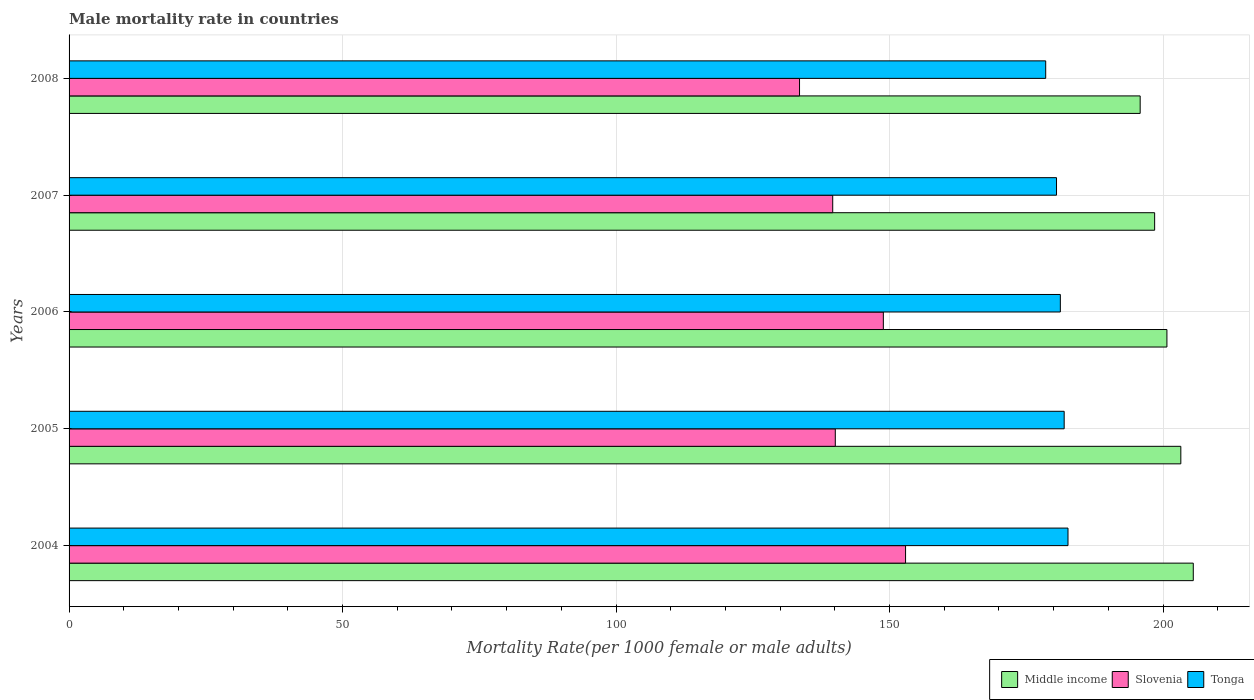How many groups of bars are there?
Ensure brevity in your answer.  5. Are the number of bars on each tick of the Y-axis equal?
Offer a terse response. Yes. How many bars are there on the 5th tick from the top?
Your answer should be compact. 3. How many bars are there on the 3rd tick from the bottom?
Your response must be concise. 3. What is the label of the 3rd group of bars from the top?
Keep it short and to the point. 2006. What is the male mortality rate in Slovenia in 2006?
Provide a succinct answer. 148.87. Across all years, what is the maximum male mortality rate in Tonga?
Provide a succinct answer. 182.63. Across all years, what is the minimum male mortality rate in Slovenia?
Give a very brief answer. 133.55. In which year was the male mortality rate in Middle income maximum?
Give a very brief answer. 2004. In which year was the male mortality rate in Slovenia minimum?
Your response must be concise. 2008. What is the total male mortality rate in Tonga in the graph?
Make the answer very short. 904.88. What is the difference between the male mortality rate in Tonga in 2004 and that in 2007?
Make the answer very short. 2.1. What is the difference between the male mortality rate in Slovenia in 2004 and the male mortality rate in Middle income in 2007?
Keep it short and to the point. -45.54. What is the average male mortality rate in Middle income per year?
Make the answer very short. 200.76. In the year 2005, what is the difference between the male mortality rate in Tonga and male mortality rate in Slovenia?
Make the answer very short. 41.84. What is the ratio of the male mortality rate in Tonga in 2005 to that in 2006?
Your answer should be compact. 1. Is the male mortality rate in Slovenia in 2004 less than that in 2005?
Ensure brevity in your answer.  No. What is the difference between the highest and the second highest male mortality rate in Slovenia?
Keep it short and to the point. 4.06. What is the difference between the highest and the lowest male mortality rate in Tonga?
Offer a very short reply. 4.07. In how many years, is the male mortality rate in Middle income greater than the average male mortality rate in Middle income taken over all years?
Your response must be concise. 2. Is the sum of the male mortality rate in Tonga in 2006 and 2007 greater than the maximum male mortality rate in Slovenia across all years?
Your answer should be compact. Yes. What does the 3rd bar from the bottom in 2004 represents?
Provide a short and direct response. Tonga. How many years are there in the graph?
Your answer should be compact. 5. What is the difference between two consecutive major ticks on the X-axis?
Keep it short and to the point. 50. Does the graph contain any zero values?
Your response must be concise. No. How many legend labels are there?
Give a very brief answer. 3. How are the legend labels stacked?
Make the answer very short. Horizontal. What is the title of the graph?
Make the answer very short. Male mortality rate in countries. What is the label or title of the X-axis?
Offer a very short reply. Mortality Rate(per 1000 female or male adults). What is the Mortality Rate(per 1000 female or male adults) of Middle income in 2004?
Your response must be concise. 205.53. What is the Mortality Rate(per 1000 female or male adults) of Slovenia in 2004?
Give a very brief answer. 152.93. What is the Mortality Rate(per 1000 female or male adults) of Tonga in 2004?
Keep it short and to the point. 182.63. What is the Mortality Rate(per 1000 female or male adults) of Middle income in 2005?
Provide a short and direct response. 203.26. What is the Mortality Rate(per 1000 female or male adults) in Slovenia in 2005?
Make the answer very short. 140.09. What is the Mortality Rate(per 1000 female or male adults) of Tonga in 2005?
Your answer should be compact. 181.93. What is the Mortality Rate(per 1000 female or male adults) of Middle income in 2006?
Provide a succinct answer. 200.72. What is the Mortality Rate(per 1000 female or male adults) in Slovenia in 2006?
Give a very brief answer. 148.87. What is the Mortality Rate(per 1000 female or male adults) in Tonga in 2006?
Offer a terse response. 181.23. What is the Mortality Rate(per 1000 female or male adults) of Middle income in 2007?
Give a very brief answer. 198.47. What is the Mortality Rate(per 1000 female or male adults) of Slovenia in 2007?
Make the answer very short. 139.62. What is the Mortality Rate(per 1000 female or male adults) of Tonga in 2007?
Ensure brevity in your answer.  180.53. What is the Mortality Rate(per 1000 female or male adults) of Middle income in 2008?
Make the answer very short. 195.83. What is the Mortality Rate(per 1000 female or male adults) in Slovenia in 2008?
Offer a very short reply. 133.55. What is the Mortality Rate(per 1000 female or male adults) of Tonga in 2008?
Your answer should be compact. 178.56. Across all years, what is the maximum Mortality Rate(per 1000 female or male adults) in Middle income?
Your answer should be very brief. 205.53. Across all years, what is the maximum Mortality Rate(per 1000 female or male adults) in Slovenia?
Your answer should be very brief. 152.93. Across all years, what is the maximum Mortality Rate(per 1000 female or male adults) in Tonga?
Provide a succinct answer. 182.63. Across all years, what is the minimum Mortality Rate(per 1000 female or male adults) of Middle income?
Ensure brevity in your answer.  195.83. Across all years, what is the minimum Mortality Rate(per 1000 female or male adults) in Slovenia?
Provide a short and direct response. 133.55. Across all years, what is the minimum Mortality Rate(per 1000 female or male adults) in Tonga?
Your answer should be very brief. 178.56. What is the total Mortality Rate(per 1000 female or male adults) in Middle income in the graph?
Give a very brief answer. 1003.81. What is the total Mortality Rate(per 1000 female or male adults) of Slovenia in the graph?
Make the answer very short. 715.05. What is the total Mortality Rate(per 1000 female or male adults) in Tonga in the graph?
Ensure brevity in your answer.  904.88. What is the difference between the Mortality Rate(per 1000 female or male adults) of Middle income in 2004 and that in 2005?
Your answer should be compact. 2.28. What is the difference between the Mortality Rate(per 1000 female or male adults) in Slovenia in 2004 and that in 2005?
Keep it short and to the point. 12.85. What is the difference between the Mortality Rate(per 1000 female or male adults) of Tonga in 2004 and that in 2005?
Offer a terse response. 0.7. What is the difference between the Mortality Rate(per 1000 female or male adults) in Middle income in 2004 and that in 2006?
Provide a short and direct response. 4.82. What is the difference between the Mortality Rate(per 1000 female or male adults) in Slovenia in 2004 and that in 2006?
Your response must be concise. 4.06. What is the difference between the Mortality Rate(per 1000 female or male adults) of Tonga in 2004 and that in 2006?
Provide a succinct answer. 1.4. What is the difference between the Mortality Rate(per 1000 female or male adults) of Middle income in 2004 and that in 2007?
Keep it short and to the point. 7.06. What is the difference between the Mortality Rate(per 1000 female or male adults) in Slovenia in 2004 and that in 2007?
Your answer should be very brief. 13.32. What is the difference between the Mortality Rate(per 1000 female or male adults) in Tonga in 2004 and that in 2007?
Make the answer very short. 2.1. What is the difference between the Mortality Rate(per 1000 female or male adults) in Middle income in 2004 and that in 2008?
Give a very brief answer. 9.71. What is the difference between the Mortality Rate(per 1000 female or male adults) in Slovenia in 2004 and that in 2008?
Offer a terse response. 19.39. What is the difference between the Mortality Rate(per 1000 female or male adults) in Tonga in 2004 and that in 2008?
Make the answer very short. 4.07. What is the difference between the Mortality Rate(per 1000 female or male adults) of Middle income in 2005 and that in 2006?
Your answer should be compact. 2.54. What is the difference between the Mortality Rate(per 1000 female or male adults) of Slovenia in 2005 and that in 2006?
Ensure brevity in your answer.  -8.79. What is the difference between the Mortality Rate(per 1000 female or male adults) in Tonga in 2005 and that in 2006?
Keep it short and to the point. 0.7. What is the difference between the Mortality Rate(per 1000 female or male adults) of Middle income in 2005 and that in 2007?
Give a very brief answer. 4.79. What is the difference between the Mortality Rate(per 1000 female or male adults) of Slovenia in 2005 and that in 2007?
Keep it short and to the point. 0.47. What is the difference between the Mortality Rate(per 1000 female or male adults) of Tonga in 2005 and that in 2007?
Ensure brevity in your answer.  1.4. What is the difference between the Mortality Rate(per 1000 female or male adults) in Middle income in 2005 and that in 2008?
Your response must be concise. 7.43. What is the difference between the Mortality Rate(per 1000 female or male adults) of Slovenia in 2005 and that in 2008?
Your answer should be compact. 6.54. What is the difference between the Mortality Rate(per 1000 female or male adults) of Tonga in 2005 and that in 2008?
Make the answer very short. 3.38. What is the difference between the Mortality Rate(per 1000 female or male adults) in Middle income in 2006 and that in 2007?
Your response must be concise. 2.25. What is the difference between the Mortality Rate(per 1000 female or male adults) of Slovenia in 2006 and that in 2007?
Provide a short and direct response. 9.26. What is the difference between the Mortality Rate(per 1000 female or male adults) of Tonga in 2006 and that in 2007?
Offer a terse response. 0.7. What is the difference between the Mortality Rate(per 1000 female or male adults) of Middle income in 2006 and that in 2008?
Your answer should be compact. 4.89. What is the difference between the Mortality Rate(per 1000 female or male adults) of Slovenia in 2006 and that in 2008?
Ensure brevity in your answer.  15.32. What is the difference between the Mortality Rate(per 1000 female or male adults) in Tonga in 2006 and that in 2008?
Provide a succinct answer. 2.68. What is the difference between the Mortality Rate(per 1000 female or male adults) in Middle income in 2007 and that in 2008?
Offer a very short reply. 2.64. What is the difference between the Mortality Rate(per 1000 female or male adults) of Slovenia in 2007 and that in 2008?
Your answer should be compact. 6.07. What is the difference between the Mortality Rate(per 1000 female or male adults) in Tonga in 2007 and that in 2008?
Your response must be concise. 1.98. What is the difference between the Mortality Rate(per 1000 female or male adults) in Middle income in 2004 and the Mortality Rate(per 1000 female or male adults) in Slovenia in 2005?
Your answer should be compact. 65.45. What is the difference between the Mortality Rate(per 1000 female or male adults) of Middle income in 2004 and the Mortality Rate(per 1000 female or male adults) of Tonga in 2005?
Ensure brevity in your answer.  23.61. What is the difference between the Mortality Rate(per 1000 female or male adults) of Slovenia in 2004 and the Mortality Rate(per 1000 female or male adults) of Tonga in 2005?
Provide a short and direct response. -29. What is the difference between the Mortality Rate(per 1000 female or male adults) of Middle income in 2004 and the Mortality Rate(per 1000 female or male adults) of Slovenia in 2006?
Provide a short and direct response. 56.66. What is the difference between the Mortality Rate(per 1000 female or male adults) of Middle income in 2004 and the Mortality Rate(per 1000 female or male adults) of Tonga in 2006?
Provide a succinct answer. 24.3. What is the difference between the Mortality Rate(per 1000 female or male adults) of Slovenia in 2004 and the Mortality Rate(per 1000 female or male adults) of Tonga in 2006?
Ensure brevity in your answer.  -28.3. What is the difference between the Mortality Rate(per 1000 female or male adults) in Middle income in 2004 and the Mortality Rate(per 1000 female or male adults) in Slovenia in 2007?
Your answer should be compact. 65.92. What is the difference between the Mortality Rate(per 1000 female or male adults) of Middle income in 2004 and the Mortality Rate(per 1000 female or male adults) of Tonga in 2007?
Ensure brevity in your answer.  25. What is the difference between the Mortality Rate(per 1000 female or male adults) of Slovenia in 2004 and the Mortality Rate(per 1000 female or male adults) of Tonga in 2007?
Ensure brevity in your answer.  -27.6. What is the difference between the Mortality Rate(per 1000 female or male adults) of Middle income in 2004 and the Mortality Rate(per 1000 female or male adults) of Slovenia in 2008?
Ensure brevity in your answer.  71.99. What is the difference between the Mortality Rate(per 1000 female or male adults) of Middle income in 2004 and the Mortality Rate(per 1000 female or male adults) of Tonga in 2008?
Make the answer very short. 26.98. What is the difference between the Mortality Rate(per 1000 female or male adults) in Slovenia in 2004 and the Mortality Rate(per 1000 female or male adults) in Tonga in 2008?
Ensure brevity in your answer.  -25.62. What is the difference between the Mortality Rate(per 1000 female or male adults) in Middle income in 2005 and the Mortality Rate(per 1000 female or male adults) in Slovenia in 2006?
Offer a very short reply. 54.39. What is the difference between the Mortality Rate(per 1000 female or male adults) of Middle income in 2005 and the Mortality Rate(per 1000 female or male adults) of Tonga in 2006?
Give a very brief answer. 22.03. What is the difference between the Mortality Rate(per 1000 female or male adults) of Slovenia in 2005 and the Mortality Rate(per 1000 female or male adults) of Tonga in 2006?
Provide a succinct answer. -41.15. What is the difference between the Mortality Rate(per 1000 female or male adults) of Middle income in 2005 and the Mortality Rate(per 1000 female or male adults) of Slovenia in 2007?
Provide a succinct answer. 63.64. What is the difference between the Mortality Rate(per 1000 female or male adults) in Middle income in 2005 and the Mortality Rate(per 1000 female or male adults) in Tonga in 2007?
Offer a terse response. 22.73. What is the difference between the Mortality Rate(per 1000 female or male adults) in Slovenia in 2005 and the Mortality Rate(per 1000 female or male adults) in Tonga in 2007?
Ensure brevity in your answer.  -40.45. What is the difference between the Mortality Rate(per 1000 female or male adults) in Middle income in 2005 and the Mortality Rate(per 1000 female or male adults) in Slovenia in 2008?
Give a very brief answer. 69.71. What is the difference between the Mortality Rate(per 1000 female or male adults) of Middle income in 2005 and the Mortality Rate(per 1000 female or male adults) of Tonga in 2008?
Your answer should be very brief. 24.7. What is the difference between the Mortality Rate(per 1000 female or male adults) in Slovenia in 2005 and the Mortality Rate(per 1000 female or male adults) in Tonga in 2008?
Offer a terse response. -38.47. What is the difference between the Mortality Rate(per 1000 female or male adults) in Middle income in 2006 and the Mortality Rate(per 1000 female or male adults) in Slovenia in 2007?
Offer a very short reply. 61.1. What is the difference between the Mortality Rate(per 1000 female or male adults) of Middle income in 2006 and the Mortality Rate(per 1000 female or male adults) of Tonga in 2007?
Ensure brevity in your answer.  20.19. What is the difference between the Mortality Rate(per 1000 female or male adults) of Slovenia in 2006 and the Mortality Rate(per 1000 female or male adults) of Tonga in 2007?
Keep it short and to the point. -31.66. What is the difference between the Mortality Rate(per 1000 female or male adults) of Middle income in 2006 and the Mortality Rate(per 1000 female or male adults) of Slovenia in 2008?
Offer a very short reply. 67.17. What is the difference between the Mortality Rate(per 1000 female or male adults) in Middle income in 2006 and the Mortality Rate(per 1000 female or male adults) in Tonga in 2008?
Offer a very short reply. 22.16. What is the difference between the Mortality Rate(per 1000 female or male adults) of Slovenia in 2006 and the Mortality Rate(per 1000 female or male adults) of Tonga in 2008?
Give a very brief answer. -29.68. What is the difference between the Mortality Rate(per 1000 female or male adults) of Middle income in 2007 and the Mortality Rate(per 1000 female or male adults) of Slovenia in 2008?
Your answer should be very brief. 64.92. What is the difference between the Mortality Rate(per 1000 female or male adults) in Middle income in 2007 and the Mortality Rate(per 1000 female or male adults) in Tonga in 2008?
Offer a very short reply. 19.92. What is the difference between the Mortality Rate(per 1000 female or male adults) of Slovenia in 2007 and the Mortality Rate(per 1000 female or male adults) of Tonga in 2008?
Offer a terse response. -38.94. What is the average Mortality Rate(per 1000 female or male adults) in Middle income per year?
Keep it short and to the point. 200.76. What is the average Mortality Rate(per 1000 female or male adults) of Slovenia per year?
Provide a short and direct response. 143.01. What is the average Mortality Rate(per 1000 female or male adults) of Tonga per year?
Make the answer very short. 180.98. In the year 2004, what is the difference between the Mortality Rate(per 1000 female or male adults) of Middle income and Mortality Rate(per 1000 female or male adults) of Slovenia?
Your response must be concise. 52.6. In the year 2004, what is the difference between the Mortality Rate(per 1000 female or male adults) of Middle income and Mortality Rate(per 1000 female or male adults) of Tonga?
Give a very brief answer. 22.91. In the year 2004, what is the difference between the Mortality Rate(per 1000 female or male adults) of Slovenia and Mortality Rate(per 1000 female or male adults) of Tonga?
Provide a short and direct response. -29.7. In the year 2005, what is the difference between the Mortality Rate(per 1000 female or male adults) of Middle income and Mortality Rate(per 1000 female or male adults) of Slovenia?
Offer a very short reply. 63.17. In the year 2005, what is the difference between the Mortality Rate(per 1000 female or male adults) in Middle income and Mortality Rate(per 1000 female or male adults) in Tonga?
Provide a short and direct response. 21.33. In the year 2005, what is the difference between the Mortality Rate(per 1000 female or male adults) in Slovenia and Mortality Rate(per 1000 female or male adults) in Tonga?
Your answer should be compact. -41.84. In the year 2006, what is the difference between the Mortality Rate(per 1000 female or male adults) in Middle income and Mortality Rate(per 1000 female or male adults) in Slovenia?
Provide a short and direct response. 51.85. In the year 2006, what is the difference between the Mortality Rate(per 1000 female or male adults) in Middle income and Mortality Rate(per 1000 female or male adults) in Tonga?
Your response must be concise. 19.49. In the year 2006, what is the difference between the Mortality Rate(per 1000 female or male adults) of Slovenia and Mortality Rate(per 1000 female or male adults) of Tonga?
Ensure brevity in your answer.  -32.36. In the year 2007, what is the difference between the Mortality Rate(per 1000 female or male adults) in Middle income and Mortality Rate(per 1000 female or male adults) in Slovenia?
Your answer should be very brief. 58.86. In the year 2007, what is the difference between the Mortality Rate(per 1000 female or male adults) of Middle income and Mortality Rate(per 1000 female or male adults) of Tonga?
Provide a succinct answer. 17.94. In the year 2007, what is the difference between the Mortality Rate(per 1000 female or male adults) in Slovenia and Mortality Rate(per 1000 female or male adults) in Tonga?
Your answer should be compact. -40.92. In the year 2008, what is the difference between the Mortality Rate(per 1000 female or male adults) in Middle income and Mortality Rate(per 1000 female or male adults) in Slovenia?
Your response must be concise. 62.28. In the year 2008, what is the difference between the Mortality Rate(per 1000 female or male adults) in Middle income and Mortality Rate(per 1000 female or male adults) in Tonga?
Offer a very short reply. 17.27. In the year 2008, what is the difference between the Mortality Rate(per 1000 female or male adults) in Slovenia and Mortality Rate(per 1000 female or male adults) in Tonga?
Provide a succinct answer. -45.01. What is the ratio of the Mortality Rate(per 1000 female or male adults) in Middle income in 2004 to that in 2005?
Your answer should be very brief. 1.01. What is the ratio of the Mortality Rate(per 1000 female or male adults) in Slovenia in 2004 to that in 2005?
Your response must be concise. 1.09. What is the ratio of the Mortality Rate(per 1000 female or male adults) of Middle income in 2004 to that in 2006?
Provide a succinct answer. 1.02. What is the ratio of the Mortality Rate(per 1000 female or male adults) in Slovenia in 2004 to that in 2006?
Provide a succinct answer. 1.03. What is the ratio of the Mortality Rate(per 1000 female or male adults) in Tonga in 2004 to that in 2006?
Make the answer very short. 1.01. What is the ratio of the Mortality Rate(per 1000 female or male adults) of Middle income in 2004 to that in 2007?
Make the answer very short. 1.04. What is the ratio of the Mortality Rate(per 1000 female or male adults) of Slovenia in 2004 to that in 2007?
Provide a succinct answer. 1.1. What is the ratio of the Mortality Rate(per 1000 female or male adults) in Tonga in 2004 to that in 2007?
Ensure brevity in your answer.  1.01. What is the ratio of the Mortality Rate(per 1000 female or male adults) in Middle income in 2004 to that in 2008?
Offer a very short reply. 1.05. What is the ratio of the Mortality Rate(per 1000 female or male adults) of Slovenia in 2004 to that in 2008?
Your answer should be compact. 1.15. What is the ratio of the Mortality Rate(per 1000 female or male adults) of Tonga in 2004 to that in 2008?
Keep it short and to the point. 1.02. What is the ratio of the Mortality Rate(per 1000 female or male adults) of Middle income in 2005 to that in 2006?
Provide a short and direct response. 1.01. What is the ratio of the Mortality Rate(per 1000 female or male adults) of Slovenia in 2005 to that in 2006?
Provide a short and direct response. 0.94. What is the ratio of the Mortality Rate(per 1000 female or male adults) of Middle income in 2005 to that in 2007?
Offer a terse response. 1.02. What is the ratio of the Mortality Rate(per 1000 female or male adults) in Slovenia in 2005 to that in 2007?
Your answer should be very brief. 1. What is the ratio of the Mortality Rate(per 1000 female or male adults) of Tonga in 2005 to that in 2007?
Ensure brevity in your answer.  1.01. What is the ratio of the Mortality Rate(per 1000 female or male adults) of Middle income in 2005 to that in 2008?
Keep it short and to the point. 1.04. What is the ratio of the Mortality Rate(per 1000 female or male adults) in Slovenia in 2005 to that in 2008?
Provide a short and direct response. 1.05. What is the ratio of the Mortality Rate(per 1000 female or male adults) in Tonga in 2005 to that in 2008?
Provide a succinct answer. 1.02. What is the ratio of the Mortality Rate(per 1000 female or male adults) in Middle income in 2006 to that in 2007?
Offer a terse response. 1.01. What is the ratio of the Mortality Rate(per 1000 female or male adults) in Slovenia in 2006 to that in 2007?
Give a very brief answer. 1.07. What is the ratio of the Mortality Rate(per 1000 female or male adults) of Tonga in 2006 to that in 2007?
Ensure brevity in your answer.  1. What is the ratio of the Mortality Rate(per 1000 female or male adults) of Middle income in 2006 to that in 2008?
Your answer should be compact. 1.02. What is the ratio of the Mortality Rate(per 1000 female or male adults) of Slovenia in 2006 to that in 2008?
Ensure brevity in your answer.  1.11. What is the ratio of the Mortality Rate(per 1000 female or male adults) of Middle income in 2007 to that in 2008?
Make the answer very short. 1.01. What is the ratio of the Mortality Rate(per 1000 female or male adults) of Slovenia in 2007 to that in 2008?
Provide a short and direct response. 1.05. What is the ratio of the Mortality Rate(per 1000 female or male adults) of Tonga in 2007 to that in 2008?
Provide a short and direct response. 1.01. What is the difference between the highest and the second highest Mortality Rate(per 1000 female or male adults) in Middle income?
Make the answer very short. 2.28. What is the difference between the highest and the second highest Mortality Rate(per 1000 female or male adults) of Slovenia?
Offer a terse response. 4.06. What is the difference between the highest and the second highest Mortality Rate(per 1000 female or male adults) of Tonga?
Keep it short and to the point. 0.7. What is the difference between the highest and the lowest Mortality Rate(per 1000 female or male adults) of Middle income?
Your response must be concise. 9.71. What is the difference between the highest and the lowest Mortality Rate(per 1000 female or male adults) in Slovenia?
Your response must be concise. 19.39. What is the difference between the highest and the lowest Mortality Rate(per 1000 female or male adults) of Tonga?
Your answer should be compact. 4.07. 